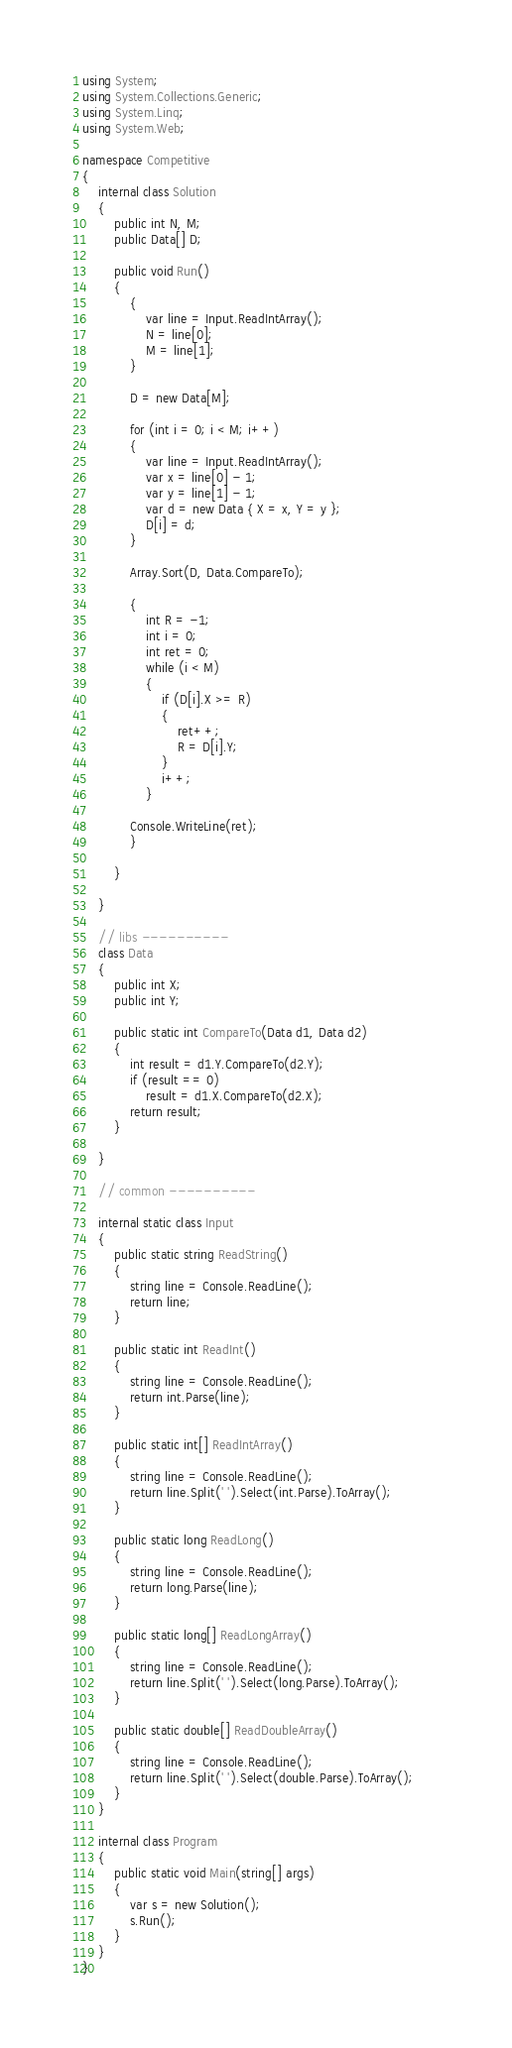<code> <loc_0><loc_0><loc_500><loc_500><_C#_>using System;
using System.Collections.Generic;
using System.Linq;
using System.Web;

namespace Competitive
{
    internal class Solution
    {
        public int N, M;
        public Data[] D;

        public void Run()
        {
            {
                var line = Input.ReadIntArray();
                N = line[0];
                M = line[1];
            }

            D = new Data[M];

            for (int i = 0; i < M; i++)
            {
                var line = Input.ReadIntArray();
                var x = line[0] - 1;
                var y = line[1] - 1;
                var d = new Data { X = x, Y = y };
                D[i] = d;
            }

            Array.Sort(D, Data.CompareTo);

            {
                int R = -1;
                int i = 0;
                int ret = 0;
                while (i < M)
                {
                    if (D[i].X >= R)
                    {
                        ret++;
                        R = D[i].Y;
                    }
                    i++;
                }

            Console.WriteLine(ret);
            }

        }

    }

    // libs ----------
    class Data
    {
        public int X;
        public int Y;

        public static int CompareTo(Data d1, Data d2)
        {
            int result = d1.Y.CompareTo(d2.Y);
            if (result == 0)
                result = d1.X.CompareTo(d2.X);
            return result;
        }

    }

    // common ----------

    internal static class Input
    {
        public static string ReadString()
        {
            string line = Console.ReadLine();
            return line;
        }

        public static int ReadInt()
        {
            string line = Console.ReadLine();
            return int.Parse(line);
        }

        public static int[] ReadIntArray()
        {
            string line = Console.ReadLine();
            return line.Split(' ').Select(int.Parse).ToArray();            
        }

        public static long ReadLong()
        {
            string line = Console.ReadLine();
            return long.Parse(line);
        }

        public static long[] ReadLongArray()
        {
            string line = Console.ReadLine();
            return line.Split(' ').Select(long.Parse).ToArray();
        }

        public static double[] ReadDoubleArray()
        {
            string line = Console.ReadLine();
            return line.Split(' ').Select(double.Parse).ToArray();
        }
    }
    
    internal class Program
    {
        public static void Main(string[] args)
        {
            var s = new Solution();
            s.Run();
        }
    }
}</code> 